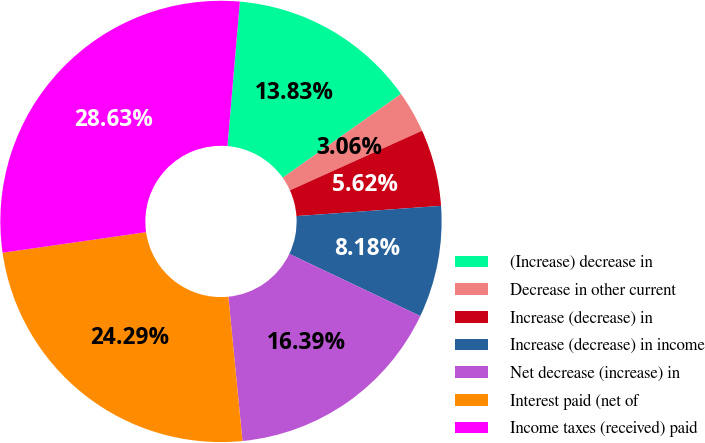Convert chart to OTSL. <chart><loc_0><loc_0><loc_500><loc_500><pie_chart><fcel>(Increase) decrease in<fcel>Decrease in other current<fcel>Increase (decrease) in<fcel>Increase (decrease) in income<fcel>Net decrease (increase) in<fcel>Interest paid (net of<fcel>Income taxes (received) paid<nl><fcel>13.83%<fcel>3.06%<fcel>5.62%<fcel>8.18%<fcel>16.39%<fcel>24.29%<fcel>28.63%<nl></chart> 